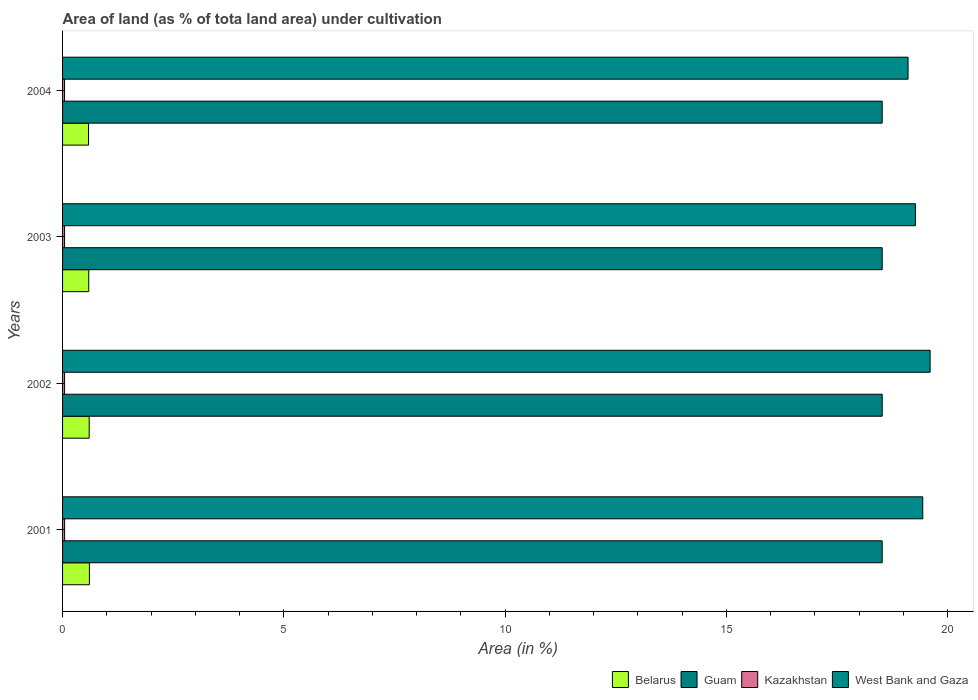How many different coloured bars are there?
Give a very brief answer. 4. Are the number of bars per tick equal to the number of legend labels?
Your answer should be compact. Yes. Are the number of bars on each tick of the Y-axis equal?
Provide a short and direct response. Yes. How many bars are there on the 2nd tick from the bottom?
Make the answer very short. 4. In how many cases, is the number of bars for a given year not equal to the number of legend labels?
Keep it short and to the point. 0. What is the percentage of land under cultivation in Belarus in 2002?
Ensure brevity in your answer.  0.6. Across all years, what is the maximum percentage of land under cultivation in West Bank and Gaza?
Your answer should be compact. 19.6. Across all years, what is the minimum percentage of land under cultivation in Kazakhstan?
Your answer should be compact. 0.04. In which year was the percentage of land under cultivation in Guam maximum?
Provide a short and direct response. 2001. In which year was the percentage of land under cultivation in Guam minimum?
Offer a very short reply. 2001. What is the total percentage of land under cultivation in Kazakhstan in the graph?
Offer a terse response. 0.18. What is the difference between the percentage of land under cultivation in Belarus in 2004 and the percentage of land under cultivation in Kazakhstan in 2001?
Your answer should be compact. 0.54. What is the average percentage of land under cultivation in Guam per year?
Make the answer very short. 18.52. In the year 2001, what is the difference between the percentage of land under cultivation in Guam and percentage of land under cultivation in Kazakhstan?
Your answer should be very brief. 18.47. What is the ratio of the percentage of land under cultivation in Kazakhstan in 2002 to that in 2004?
Your answer should be compact. 1.03. Is the percentage of land under cultivation in West Bank and Gaza in 2001 less than that in 2004?
Your answer should be very brief. No. Is the difference between the percentage of land under cultivation in Guam in 2001 and 2003 greater than the difference between the percentage of land under cultivation in Kazakhstan in 2001 and 2003?
Your answer should be very brief. No. What is the difference between the highest and the second highest percentage of land under cultivation in West Bank and Gaza?
Keep it short and to the point. 0.17. What is the difference between the highest and the lowest percentage of land under cultivation in West Bank and Gaza?
Make the answer very short. 0.5. In how many years, is the percentage of land under cultivation in West Bank and Gaza greater than the average percentage of land under cultivation in West Bank and Gaza taken over all years?
Provide a short and direct response. 2. Is it the case that in every year, the sum of the percentage of land under cultivation in West Bank and Gaza and percentage of land under cultivation in Belarus is greater than the sum of percentage of land under cultivation in Guam and percentage of land under cultivation in Kazakhstan?
Keep it short and to the point. Yes. What does the 3rd bar from the top in 2001 represents?
Provide a succinct answer. Guam. What does the 4th bar from the bottom in 2004 represents?
Ensure brevity in your answer.  West Bank and Gaza. Is it the case that in every year, the sum of the percentage of land under cultivation in Guam and percentage of land under cultivation in Kazakhstan is greater than the percentage of land under cultivation in Belarus?
Make the answer very short. Yes. What is the difference between two consecutive major ticks on the X-axis?
Give a very brief answer. 5. Are the values on the major ticks of X-axis written in scientific E-notation?
Make the answer very short. No. Does the graph contain any zero values?
Keep it short and to the point. No. Does the graph contain grids?
Provide a short and direct response. No. How many legend labels are there?
Your answer should be compact. 4. What is the title of the graph?
Your answer should be compact. Area of land (as % of tota land area) under cultivation. What is the label or title of the X-axis?
Your answer should be compact. Area (in %). What is the Area (in %) of Belarus in 2001?
Keep it short and to the point. 0.61. What is the Area (in %) of Guam in 2001?
Offer a very short reply. 18.52. What is the Area (in %) in Kazakhstan in 2001?
Provide a succinct answer. 0.05. What is the Area (in %) of West Bank and Gaza in 2001?
Provide a short and direct response. 19.44. What is the Area (in %) of Belarus in 2002?
Offer a terse response. 0.6. What is the Area (in %) in Guam in 2002?
Your response must be concise. 18.52. What is the Area (in %) of Kazakhstan in 2002?
Your answer should be very brief. 0.05. What is the Area (in %) of West Bank and Gaza in 2002?
Offer a terse response. 19.6. What is the Area (in %) in Belarus in 2003?
Keep it short and to the point. 0.59. What is the Area (in %) of Guam in 2003?
Provide a succinct answer. 18.52. What is the Area (in %) of Kazakhstan in 2003?
Offer a very short reply. 0.05. What is the Area (in %) of West Bank and Gaza in 2003?
Your response must be concise. 19.27. What is the Area (in %) in Belarus in 2004?
Give a very brief answer. 0.59. What is the Area (in %) of Guam in 2004?
Provide a succinct answer. 18.52. What is the Area (in %) of Kazakhstan in 2004?
Offer a very short reply. 0.04. What is the Area (in %) of West Bank and Gaza in 2004?
Give a very brief answer. 19.1. Across all years, what is the maximum Area (in %) of Belarus?
Give a very brief answer. 0.61. Across all years, what is the maximum Area (in %) in Guam?
Offer a very short reply. 18.52. Across all years, what is the maximum Area (in %) in Kazakhstan?
Ensure brevity in your answer.  0.05. Across all years, what is the maximum Area (in %) of West Bank and Gaza?
Ensure brevity in your answer.  19.6. Across all years, what is the minimum Area (in %) of Belarus?
Offer a terse response. 0.59. Across all years, what is the minimum Area (in %) of Guam?
Provide a short and direct response. 18.52. Across all years, what is the minimum Area (in %) of Kazakhstan?
Provide a short and direct response. 0.04. Across all years, what is the minimum Area (in %) of West Bank and Gaza?
Ensure brevity in your answer.  19.1. What is the total Area (in %) of Belarus in the graph?
Your answer should be compact. 2.39. What is the total Area (in %) of Guam in the graph?
Provide a succinct answer. 74.07. What is the total Area (in %) of Kazakhstan in the graph?
Provide a succinct answer. 0.18. What is the total Area (in %) in West Bank and Gaza in the graph?
Offer a terse response. 77.41. What is the difference between the Area (in %) in Belarus in 2001 and that in 2002?
Offer a very short reply. 0. What is the difference between the Area (in %) of Guam in 2001 and that in 2002?
Provide a succinct answer. 0. What is the difference between the Area (in %) in Kazakhstan in 2001 and that in 2002?
Provide a succinct answer. 0. What is the difference between the Area (in %) of West Bank and Gaza in 2001 and that in 2002?
Make the answer very short. -0.17. What is the difference between the Area (in %) of Belarus in 2001 and that in 2003?
Make the answer very short. 0.01. What is the difference between the Area (in %) of Kazakhstan in 2001 and that in 2003?
Ensure brevity in your answer.  0. What is the difference between the Area (in %) of West Bank and Gaza in 2001 and that in 2003?
Provide a succinct answer. 0.17. What is the difference between the Area (in %) of Belarus in 2001 and that in 2004?
Give a very brief answer. 0.02. What is the difference between the Area (in %) in Kazakhstan in 2001 and that in 2004?
Your answer should be compact. 0. What is the difference between the Area (in %) of West Bank and Gaza in 2001 and that in 2004?
Your answer should be compact. 0.33. What is the difference between the Area (in %) in Belarus in 2002 and that in 2003?
Your response must be concise. 0.01. What is the difference between the Area (in %) of West Bank and Gaza in 2002 and that in 2003?
Keep it short and to the point. 0.33. What is the difference between the Area (in %) of Belarus in 2002 and that in 2004?
Provide a succinct answer. 0.01. What is the difference between the Area (in %) in Kazakhstan in 2002 and that in 2004?
Keep it short and to the point. 0. What is the difference between the Area (in %) in West Bank and Gaza in 2002 and that in 2004?
Keep it short and to the point. 0.5. What is the difference between the Area (in %) of Belarus in 2003 and that in 2004?
Your response must be concise. 0. What is the difference between the Area (in %) in Kazakhstan in 2003 and that in 2004?
Ensure brevity in your answer.  0. What is the difference between the Area (in %) of West Bank and Gaza in 2003 and that in 2004?
Provide a succinct answer. 0.17. What is the difference between the Area (in %) of Belarus in 2001 and the Area (in %) of Guam in 2002?
Give a very brief answer. -17.91. What is the difference between the Area (in %) in Belarus in 2001 and the Area (in %) in Kazakhstan in 2002?
Your answer should be compact. 0.56. What is the difference between the Area (in %) in Belarus in 2001 and the Area (in %) in West Bank and Gaza in 2002?
Provide a short and direct response. -18.99. What is the difference between the Area (in %) in Guam in 2001 and the Area (in %) in Kazakhstan in 2002?
Give a very brief answer. 18.47. What is the difference between the Area (in %) in Guam in 2001 and the Area (in %) in West Bank and Gaza in 2002?
Give a very brief answer. -1.08. What is the difference between the Area (in %) of Kazakhstan in 2001 and the Area (in %) of West Bank and Gaza in 2002?
Ensure brevity in your answer.  -19.55. What is the difference between the Area (in %) in Belarus in 2001 and the Area (in %) in Guam in 2003?
Make the answer very short. -17.91. What is the difference between the Area (in %) in Belarus in 2001 and the Area (in %) in Kazakhstan in 2003?
Keep it short and to the point. 0.56. What is the difference between the Area (in %) of Belarus in 2001 and the Area (in %) of West Bank and Gaza in 2003?
Make the answer very short. -18.66. What is the difference between the Area (in %) in Guam in 2001 and the Area (in %) in Kazakhstan in 2003?
Ensure brevity in your answer.  18.47. What is the difference between the Area (in %) of Guam in 2001 and the Area (in %) of West Bank and Gaza in 2003?
Provide a short and direct response. -0.75. What is the difference between the Area (in %) in Kazakhstan in 2001 and the Area (in %) in West Bank and Gaza in 2003?
Give a very brief answer. -19.22. What is the difference between the Area (in %) of Belarus in 2001 and the Area (in %) of Guam in 2004?
Offer a very short reply. -17.91. What is the difference between the Area (in %) in Belarus in 2001 and the Area (in %) in Kazakhstan in 2004?
Offer a terse response. 0.56. What is the difference between the Area (in %) in Belarus in 2001 and the Area (in %) in West Bank and Gaza in 2004?
Provide a short and direct response. -18.5. What is the difference between the Area (in %) of Guam in 2001 and the Area (in %) of Kazakhstan in 2004?
Ensure brevity in your answer.  18.47. What is the difference between the Area (in %) of Guam in 2001 and the Area (in %) of West Bank and Gaza in 2004?
Offer a very short reply. -0.58. What is the difference between the Area (in %) in Kazakhstan in 2001 and the Area (in %) in West Bank and Gaza in 2004?
Make the answer very short. -19.06. What is the difference between the Area (in %) in Belarus in 2002 and the Area (in %) in Guam in 2003?
Provide a short and direct response. -17.92. What is the difference between the Area (in %) of Belarus in 2002 and the Area (in %) of Kazakhstan in 2003?
Make the answer very short. 0.56. What is the difference between the Area (in %) in Belarus in 2002 and the Area (in %) in West Bank and Gaza in 2003?
Keep it short and to the point. -18.67. What is the difference between the Area (in %) in Guam in 2002 and the Area (in %) in Kazakhstan in 2003?
Give a very brief answer. 18.47. What is the difference between the Area (in %) in Guam in 2002 and the Area (in %) in West Bank and Gaza in 2003?
Provide a succinct answer. -0.75. What is the difference between the Area (in %) of Kazakhstan in 2002 and the Area (in %) of West Bank and Gaza in 2003?
Your answer should be very brief. -19.22. What is the difference between the Area (in %) in Belarus in 2002 and the Area (in %) in Guam in 2004?
Provide a succinct answer. -17.92. What is the difference between the Area (in %) in Belarus in 2002 and the Area (in %) in Kazakhstan in 2004?
Make the answer very short. 0.56. What is the difference between the Area (in %) in Belarus in 2002 and the Area (in %) in West Bank and Gaza in 2004?
Provide a succinct answer. -18.5. What is the difference between the Area (in %) of Guam in 2002 and the Area (in %) of Kazakhstan in 2004?
Offer a very short reply. 18.47. What is the difference between the Area (in %) in Guam in 2002 and the Area (in %) in West Bank and Gaza in 2004?
Your answer should be compact. -0.58. What is the difference between the Area (in %) in Kazakhstan in 2002 and the Area (in %) in West Bank and Gaza in 2004?
Offer a terse response. -19.06. What is the difference between the Area (in %) of Belarus in 2003 and the Area (in %) of Guam in 2004?
Offer a terse response. -17.93. What is the difference between the Area (in %) of Belarus in 2003 and the Area (in %) of Kazakhstan in 2004?
Your answer should be compact. 0.55. What is the difference between the Area (in %) in Belarus in 2003 and the Area (in %) in West Bank and Gaza in 2004?
Ensure brevity in your answer.  -18.51. What is the difference between the Area (in %) in Guam in 2003 and the Area (in %) in Kazakhstan in 2004?
Offer a very short reply. 18.47. What is the difference between the Area (in %) in Guam in 2003 and the Area (in %) in West Bank and Gaza in 2004?
Provide a succinct answer. -0.58. What is the difference between the Area (in %) of Kazakhstan in 2003 and the Area (in %) of West Bank and Gaza in 2004?
Keep it short and to the point. -19.06. What is the average Area (in %) in Belarus per year?
Provide a succinct answer. 0.6. What is the average Area (in %) of Guam per year?
Your response must be concise. 18.52. What is the average Area (in %) in Kazakhstan per year?
Your answer should be very brief. 0.05. What is the average Area (in %) of West Bank and Gaza per year?
Give a very brief answer. 19.35. In the year 2001, what is the difference between the Area (in %) in Belarus and Area (in %) in Guam?
Keep it short and to the point. -17.91. In the year 2001, what is the difference between the Area (in %) in Belarus and Area (in %) in Kazakhstan?
Your answer should be very brief. 0.56. In the year 2001, what is the difference between the Area (in %) in Belarus and Area (in %) in West Bank and Gaza?
Your answer should be very brief. -18.83. In the year 2001, what is the difference between the Area (in %) in Guam and Area (in %) in Kazakhstan?
Your answer should be very brief. 18.47. In the year 2001, what is the difference between the Area (in %) of Guam and Area (in %) of West Bank and Gaza?
Give a very brief answer. -0.92. In the year 2001, what is the difference between the Area (in %) of Kazakhstan and Area (in %) of West Bank and Gaza?
Your response must be concise. -19.39. In the year 2002, what is the difference between the Area (in %) of Belarus and Area (in %) of Guam?
Give a very brief answer. -17.92. In the year 2002, what is the difference between the Area (in %) of Belarus and Area (in %) of Kazakhstan?
Provide a succinct answer. 0.56. In the year 2002, what is the difference between the Area (in %) of Belarus and Area (in %) of West Bank and Gaza?
Offer a terse response. -19. In the year 2002, what is the difference between the Area (in %) of Guam and Area (in %) of Kazakhstan?
Offer a terse response. 18.47. In the year 2002, what is the difference between the Area (in %) of Guam and Area (in %) of West Bank and Gaza?
Offer a terse response. -1.08. In the year 2002, what is the difference between the Area (in %) in Kazakhstan and Area (in %) in West Bank and Gaza?
Provide a short and direct response. -19.56. In the year 2003, what is the difference between the Area (in %) of Belarus and Area (in %) of Guam?
Give a very brief answer. -17.93. In the year 2003, what is the difference between the Area (in %) in Belarus and Area (in %) in Kazakhstan?
Offer a very short reply. 0.55. In the year 2003, what is the difference between the Area (in %) of Belarus and Area (in %) of West Bank and Gaza?
Give a very brief answer. -18.68. In the year 2003, what is the difference between the Area (in %) in Guam and Area (in %) in Kazakhstan?
Your response must be concise. 18.47. In the year 2003, what is the difference between the Area (in %) in Guam and Area (in %) in West Bank and Gaza?
Make the answer very short. -0.75. In the year 2003, what is the difference between the Area (in %) of Kazakhstan and Area (in %) of West Bank and Gaza?
Offer a terse response. -19.22. In the year 2004, what is the difference between the Area (in %) in Belarus and Area (in %) in Guam?
Your answer should be very brief. -17.93. In the year 2004, what is the difference between the Area (in %) of Belarus and Area (in %) of Kazakhstan?
Your answer should be very brief. 0.54. In the year 2004, what is the difference between the Area (in %) in Belarus and Area (in %) in West Bank and Gaza?
Your response must be concise. -18.52. In the year 2004, what is the difference between the Area (in %) in Guam and Area (in %) in Kazakhstan?
Make the answer very short. 18.47. In the year 2004, what is the difference between the Area (in %) in Guam and Area (in %) in West Bank and Gaza?
Provide a short and direct response. -0.58. In the year 2004, what is the difference between the Area (in %) in Kazakhstan and Area (in %) in West Bank and Gaza?
Provide a short and direct response. -19.06. What is the ratio of the Area (in %) of Guam in 2001 to that in 2002?
Give a very brief answer. 1. What is the ratio of the Area (in %) in Kazakhstan in 2001 to that in 2002?
Offer a terse response. 1.02. What is the ratio of the Area (in %) of West Bank and Gaza in 2001 to that in 2002?
Your answer should be very brief. 0.99. What is the ratio of the Area (in %) in Belarus in 2001 to that in 2003?
Keep it short and to the point. 1.02. What is the ratio of the Area (in %) in Guam in 2001 to that in 2003?
Give a very brief answer. 1. What is the ratio of the Area (in %) in Kazakhstan in 2001 to that in 2003?
Your answer should be compact. 1.03. What is the ratio of the Area (in %) of West Bank and Gaza in 2001 to that in 2003?
Your response must be concise. 1.01. What is the ratio of the Area (in %) in Belarus in 2001 to that in 2004?
Make the answer very short. 1.03. What is the ratio of the Area (in %) in Guam in 2001 to that in 2004?
Offer a very short reply. 1. What is the ratio of the Area (in %) in Kazakhstan in 2001 to that in 2004?
Your answer should be very brief. 1.05. What is the ratio of the Area (in %) in West Bank and Gaza in 2001 to that in 2004?
Give a very brief answer. 1.02. What is the ratio of the Area (in %) of Belarus in 2002 to that in 2003?
Offer a terse response. 1.02. What is the ratio of the Area (in %) in Guam in 2002 to that in 2003?
Offer a very short reply. 1. What is the ratio of the Area (in %) in Kazakhstan in 2002 to that in 2003?
Your answer should be very brief. 1.01. What is the ratio of the Area (in %) in West Bank and Gaza in 2002 to that in 2003?
Provide a succinct answer. 1.02. What is the ratio of the Area (in %) of Belarus in 2002 to that in 2004?
Your answer should be compact. 1.03. What is the ratio of the Area (in %) of Kazakhstan in 2002 to that in 2004?
Make the answer very short. 1.03. What is the ratio of the Area (in %) of West Bank and Gaza in 2002 to that in 2004?
Offer a terse response. 1.03. What is the ratio of the Area (in %) of Belarus in 2003 to that in 2004?
Your answer should be very brief. 1.01. What is the ratio of the Area (in %) in Guam in 2003 to that in 2004?
Your answer should be compact. 1. What is the ratio of the Area (in %) in Kazakhstan in 2003 to that in 2004?
Your answer should be very brief. 1.02. What is the ratio of the Area (in %) of West Bank and Gaza in 2003 to that in 2004?
Your response must be concise. 1.01. What is the difference between the highest and the second highest Area (in %) in Belarus?
Give a very brief answer. 0. What is the difference between the highest and the second highest Area (in %) of Guam?
Ensure brevity in your answer.  0. What is the difference between the highest and the second highest Area (in %) of Kazakhstan?
Provide a short and direct response. 0. What is the difference between the highest and the second highest Area (in %) in West Bank and Gaza?
Provide a succinct answer. 0.17. What is the difference between the highest and the lowest Area (in %) in Belarus?
Ensure brevity in your answer.  0.02. What is the difference between the highest and the lowest Area (in %) in Kazakhstan?
Provide a succinct answer. 0. What is the difference between the highest and the lowest Area (in %) in West Bank and Gaza?
Provide a short and direct response. 0.5. 